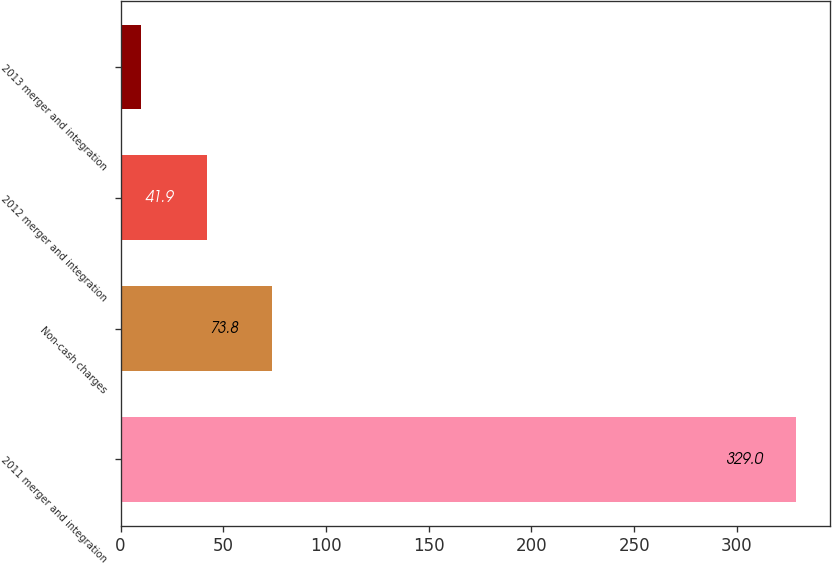<chart> <loc_0><loc_0><loc_500><loc_500><bar_chart><fcel>2011 merger and integration<fcel>Non-cash charges<fcel>2012 merger and integration<fcel>2013 merger and integration<nl><fcel>329<fcel>73.8<fcel>41.9<fcel>10<nl></chart> 